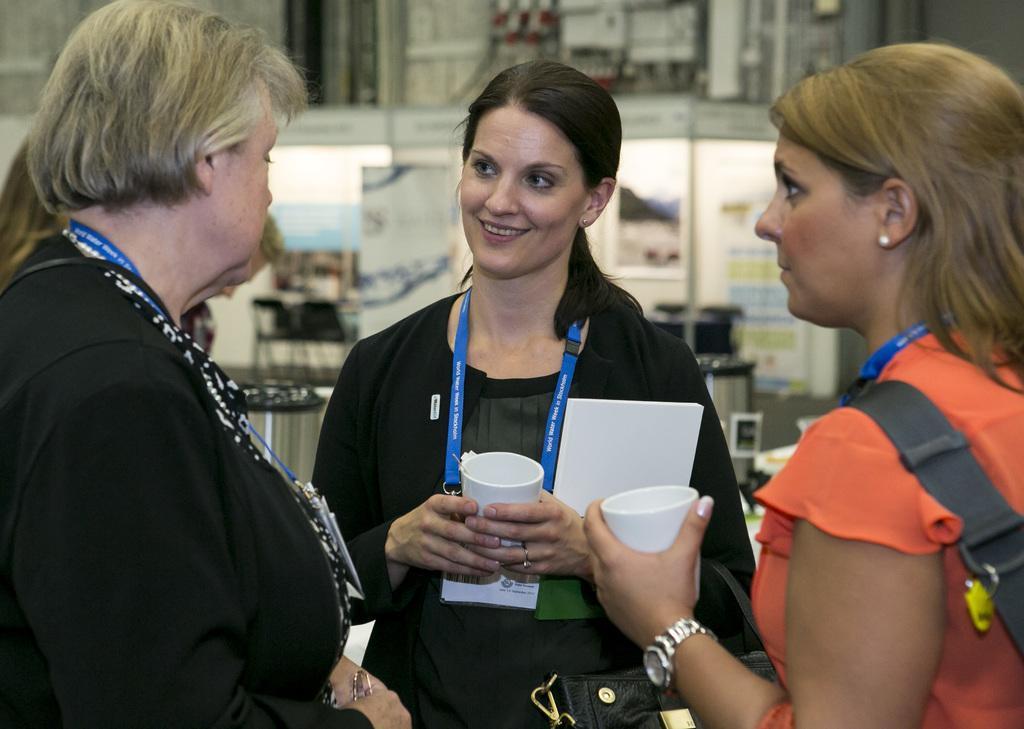How would you summarize this image in a sentence or two? In the foreground of this image, there are three women standing and talking to each other and holding cups in their hands. In the background, there is a wall, banners, chairs, and a table. 